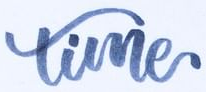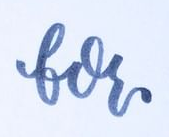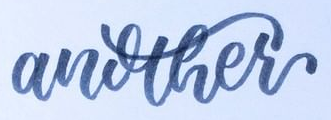Identify the words shown in these images in order, separated by a semicolon. time; for; another 